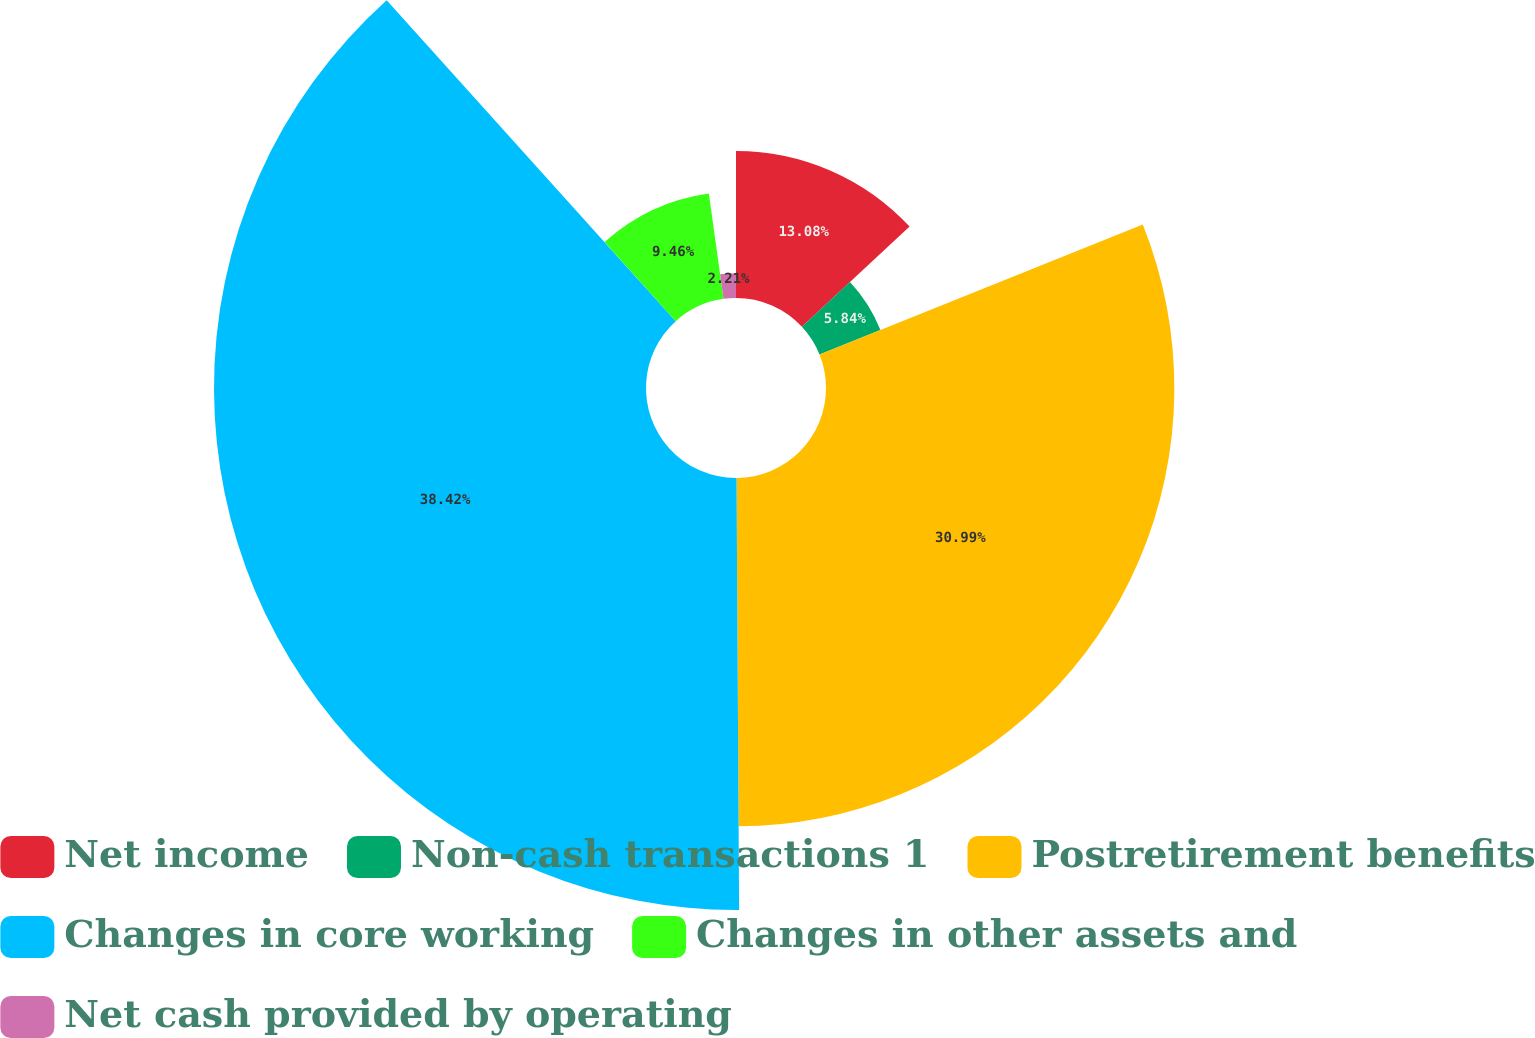Convert chart to OTSL. <chart><loc_0><loc_0><loc_500><loc_500><pie_chart><fcel>Net income<fcel>Non-cash transactions 1<fcel>Postretirement benefits<fcel>Changes in core working<fcel>Changes in other assets and<fcel>Net cash provided by operating<nl><fcel>13.08%<fcel>5.84%<fcel>30.99%<fcel>38.43%<fcel>9.46%<fcel>2.21%<nl></chart> 